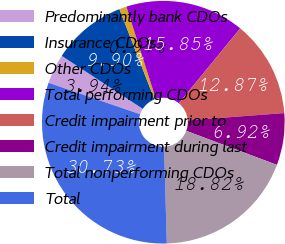Convert chart. <chart><loc_0><loc_0><loc_500><loc_500><pie_chart><fcel>Predominantly bank CDOs<fcel>Insurance CDOs<fcel>Other CDOs<fcel>Total performing CDOs<fcel>Credit impairment prior to<fcel>Credit impairment during last<fcel>Total nonperforming CDOs<fcel>Total<nl><fcel>3.94%<fcel>9.9%<fcel>0.97%<fcel>15.85%<fcel>12.87%<fcel>6.92%<fcel>18.82%<fcel>30.73%<nl></chart> 